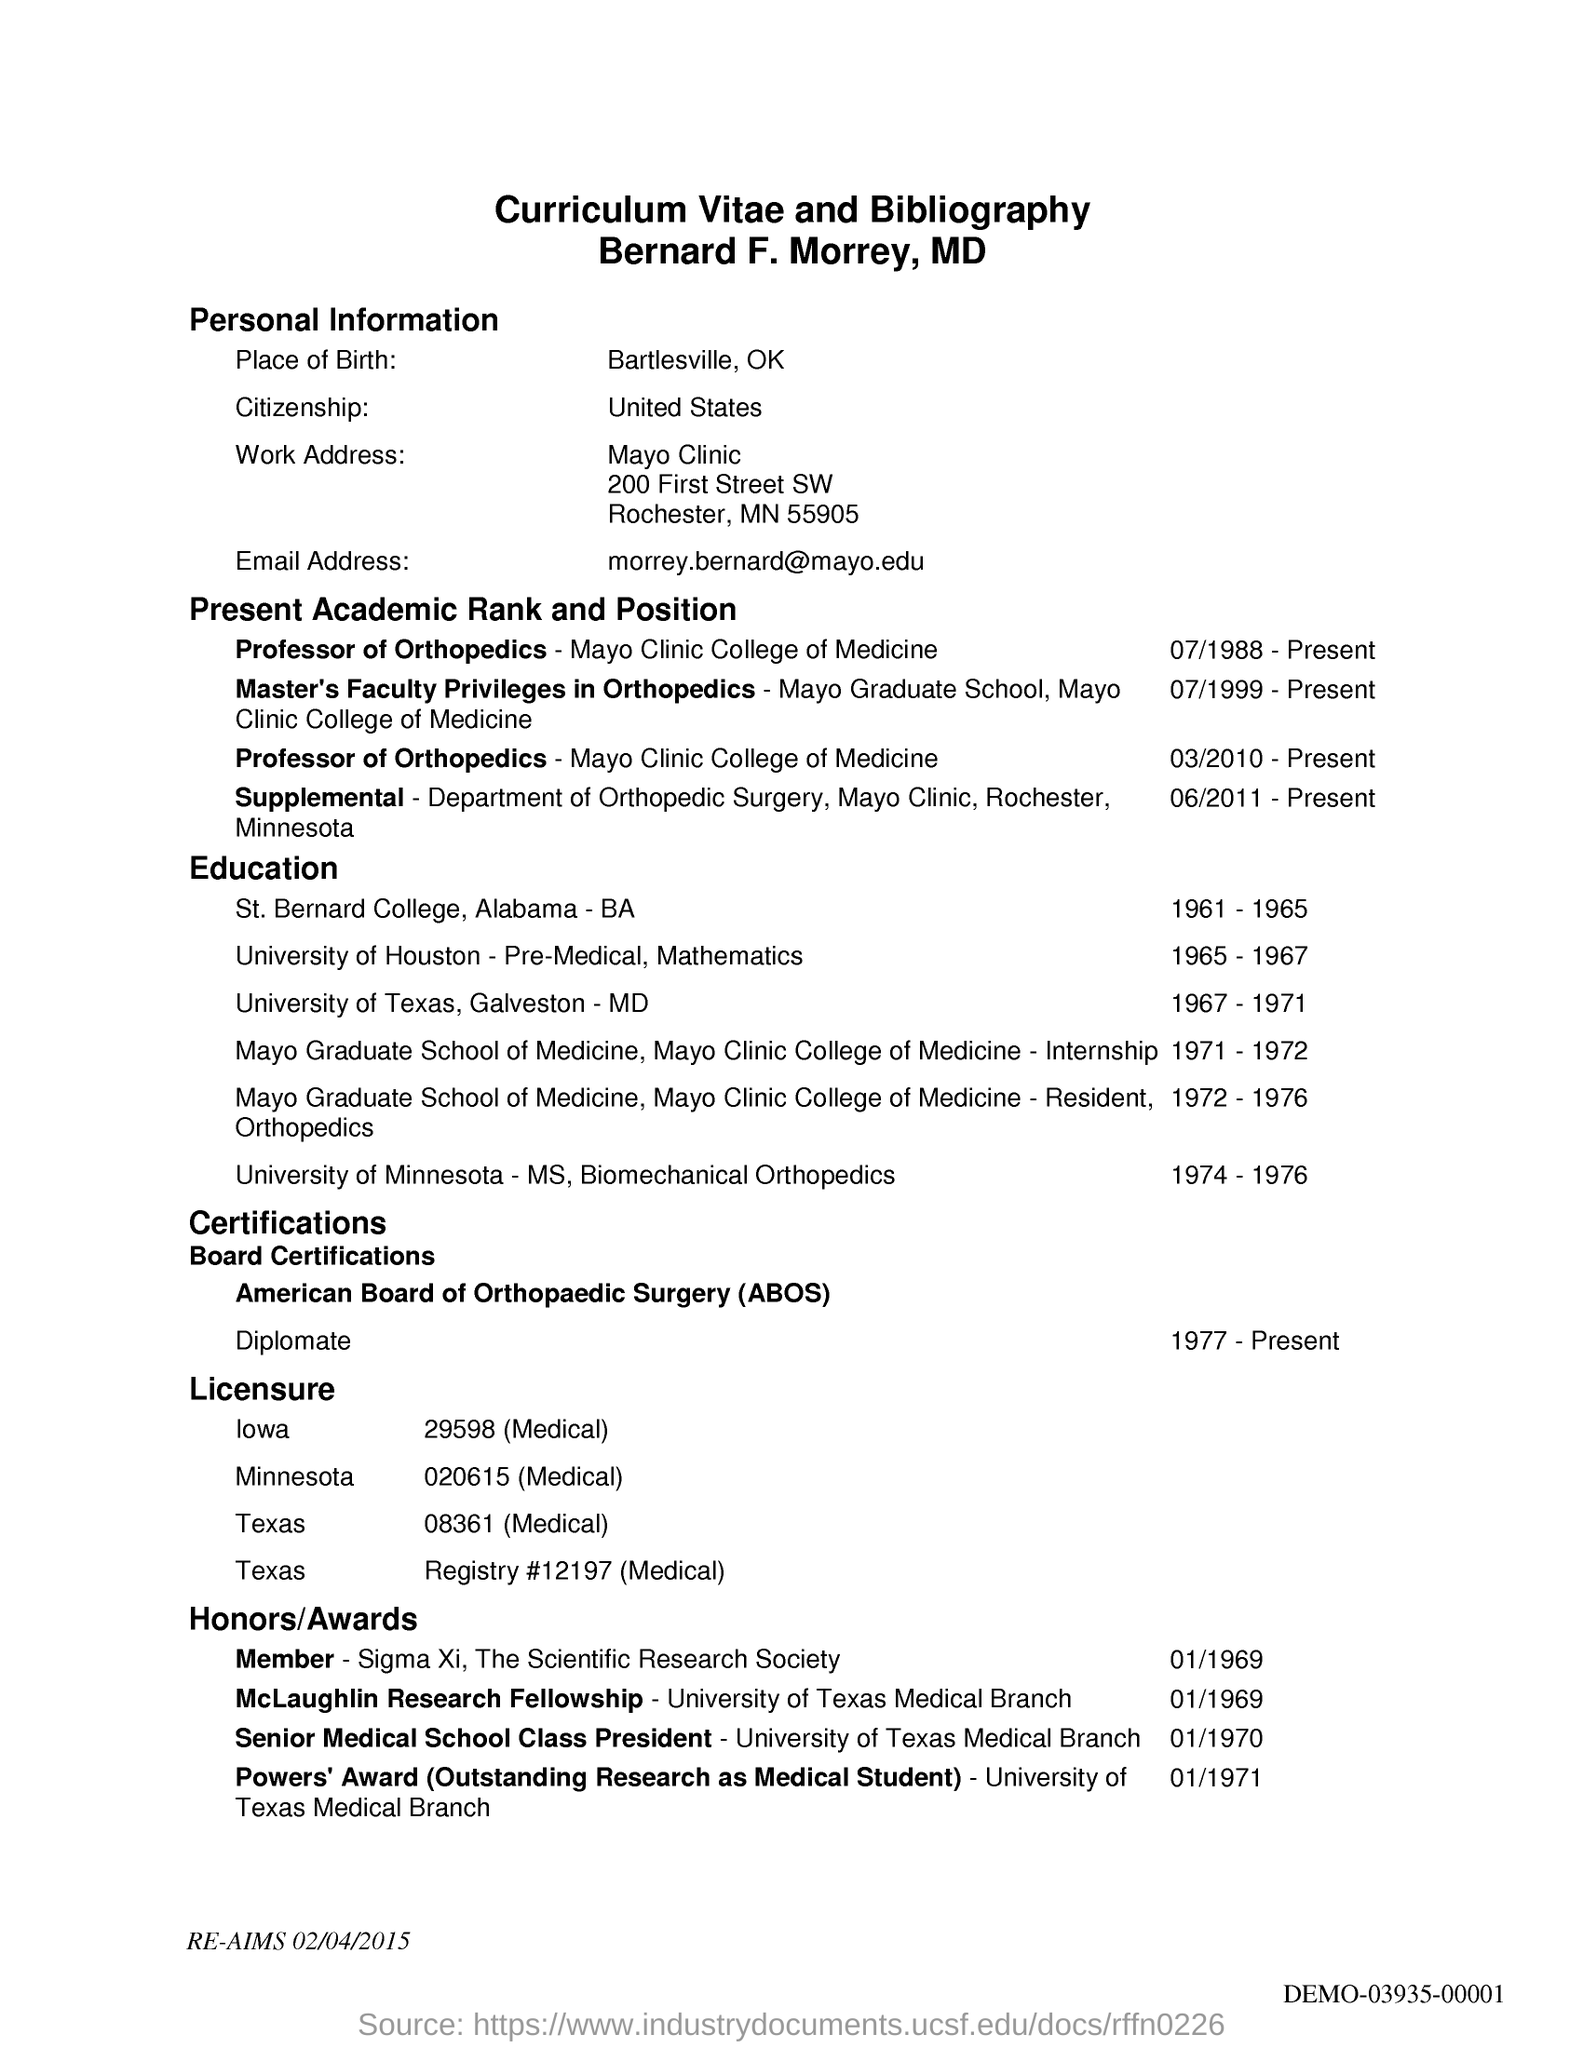List a handful of essential elements in this visual. The applicant's email address is [morrey.bernard@mayo.edu](mailto:morrey.bernard@mayo.edu). The applicant's country of citizenship is the United States. The applicant's place of birth is Bartlesville, Oklahoma. 